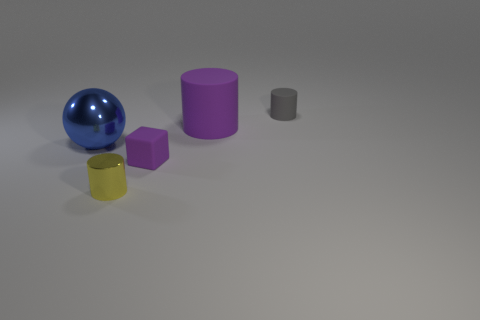What size is the purple matte cylinder?
Make the answer very short. Large. What number of big metallic things are behind the small metal cylinder?
Your response must be concise. 1. The purple object that is the same shape as the yellow shiny thing is what size?
Your answer should be very brief. Large. There is a object that is behind the small purple rubber object and on the left side of the purple rubber cylinder; what is its size?
Your answer should be compact. Large. Is the color of the big rubber cylinder the same as the matte thing that is in front of the large purple matte cylinder?
Your response must be concise. Yes. What number of brown objects are either large balls or tiny cubes?
Your answer should be very brief. 0. The big blue object is what shape?
Provide a succinct answer. Sphere. What number of other objects are the same shape as the gray thing?
Provide a short and direct response. 2. The tiny matte thing that is in front of the gray object is what color?
Keep it short and to the point. Purple. Do the small purple block and the big purple cylinder have the same material?
Your response must be concise. Yes. 